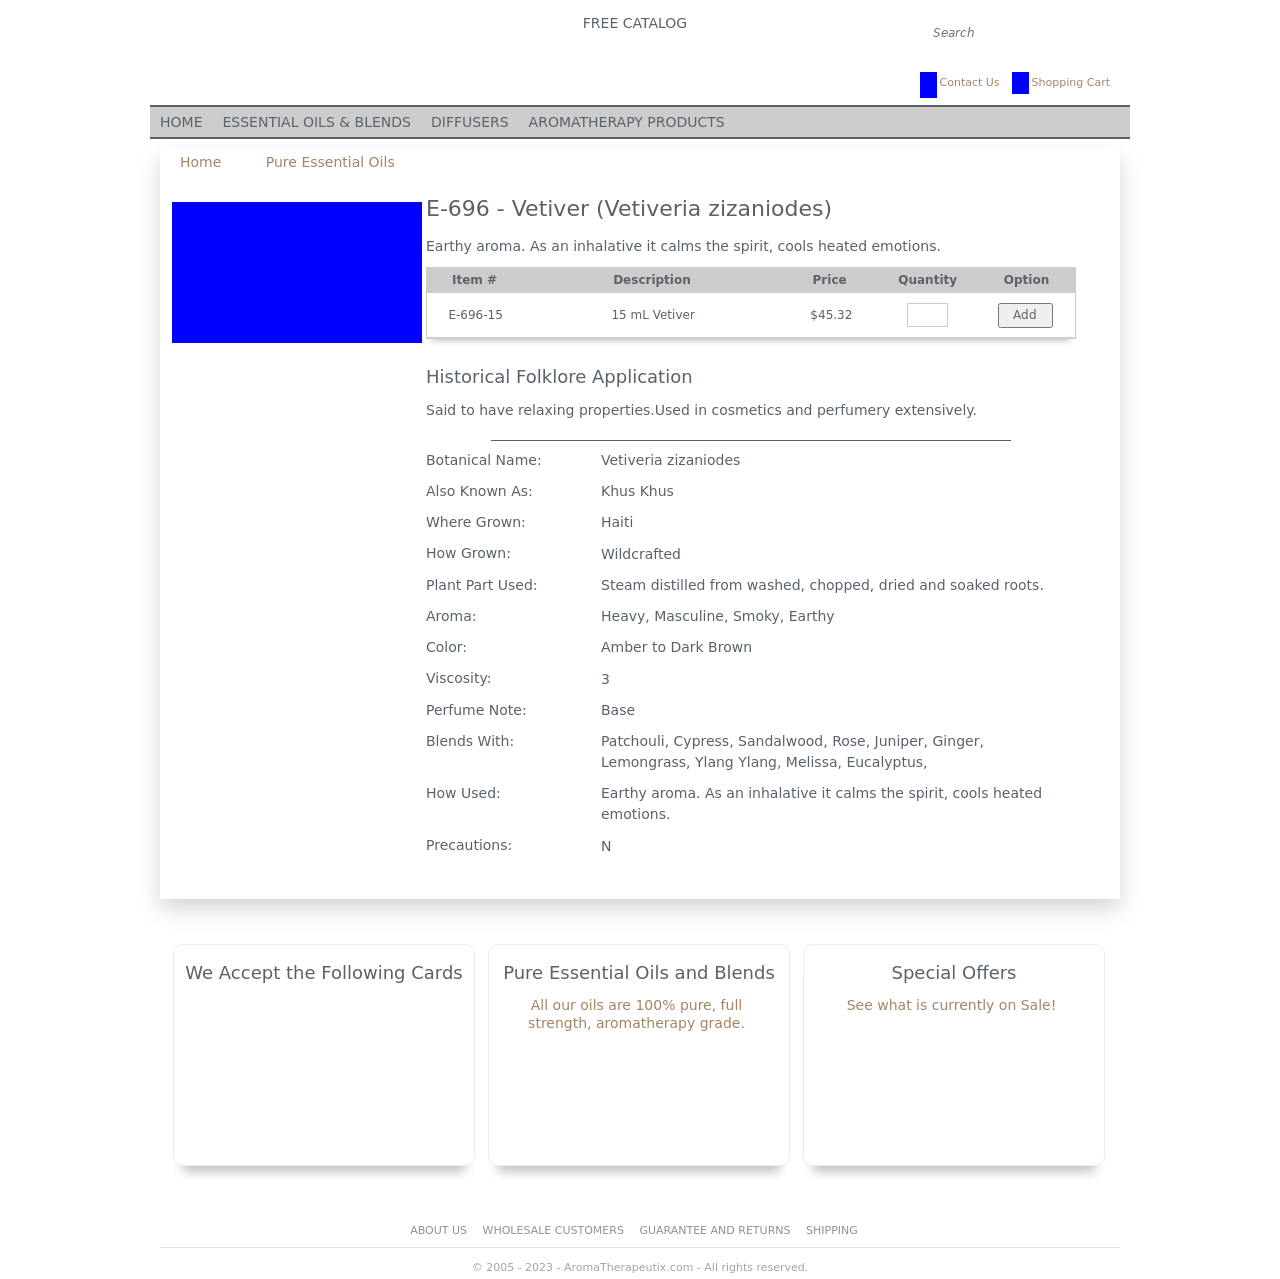Can you tell me more about the specific properties of Vetiver essential oil as shown in the image? Certainly! Vetiver essential oil, as highlighted in the image, is well-known for its calming and grounding properties. It is steam distilled from the roots, which is why it has a deep, earthy and smoky aroma. It is commonly used to stabilize emotions and cool down heated situations. Furthermore, it has a viscosity rating of 3, meaning it is moderately thick like pancake syrup, and its color ranges from amber to dark brown. Vetiver oil blends well with other oils such as Patchouli, Sandalwood, and Rose, making it versatile for various aromatherapeutic blends.  What are the precautions and historical uses of Vetiver oil? Vetiver oil does not have specific precautions associated with its use, as noted in the image it's safe to use under the classification 'N', which implies no known contraindications. Historically, Vetiver oil has been used for its relaxing effects in both the mind and body. It has been a popular choice in cosmetics and perfumery due to its deep and complex scent profile. Additionally, it is purported to have applications in traditional medicine, particularly for its calming effects that help in anxiety relief and sleep aid. 